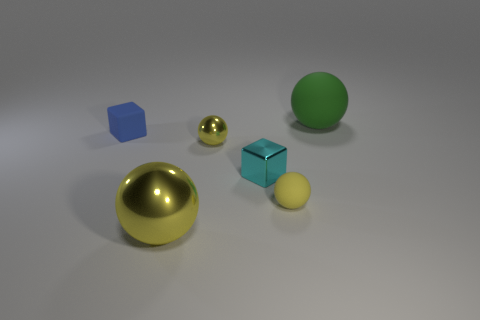Is the metal block the same color as the large metallic object?
Make the answer very short. No. What color is the matte object that is both to the right of the cyan metallic block and left of the large green matte thing?
Give a very brief answer. Yellow. How many spheres are either big yellow metallic objects or tiny yellow metal objects?
Make the answer very short. 2. Is the shape of the green rubber object the same as the tiny matte thing right of the rubber block?
Offer a very short reply. Yes. There is a metal object that is left of the cyan metallic thing and behind the small matte sphere; what size is it?
Keep it short and to the point. Small. The small blue object has what shape?
Offer a very short reply. Cube. There is a small block in front of the small blue object; are there any tiny blocks to the left of it?
Your answer should be very brief. Yes. How many metallic balls are on the right side of the big thing that is left of the large green rubber object?
Offer a very short reply. 1. What material is the blue block that is the same size as the cyan shiny object?
Your answer should be compact. Rubber. There is a large object left of the large green matte thing; is it the same shape as the large green rubber thing?
Provide a short and direct response. Yes. 